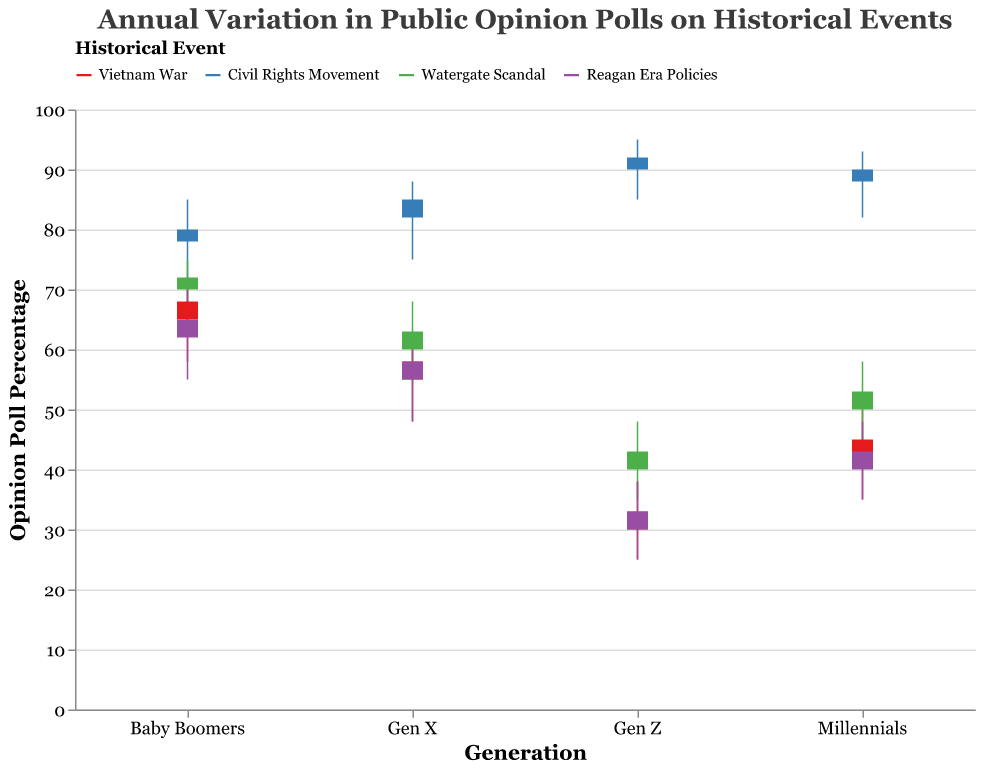What historical event had the highest closing opinion percentage for Baby Boomers? To find this, we look for the historical event where the “Close” value for Baby Boomers is the highest. Baby Boomers have the highest close percentage of 80 for the Civil Rights Movement.
Answer: Civil Rights Movement Which generation had the lowest high opinion percentage for the Vietnam War in 2020? For the Vietnam War in 2020, compare the “High” values among the generations. Gen Z has the lowest high opinion percentage (38).
Answer: Gen Z How does the opening opinion percentage for Reagan Era Policies compare between Baby Boomers and Millennials? Compare the "Open" values for Reagan Era Policies: Baby Boomers (62), Millennials (40). Baby Boomers have a higher opening opinion percentage.
Answer: Baby Boomers have a higher opening opinion What is the range of opinion percentages for Millennials on the Watergate Scandal in 2022? The range is calculated by subtracting the “Low” value from the “High” value for Millennials in 2022 on the Watergate Scandal: 58 - 45 = 13.
Answer: 13 For Gen X, which historical event in the data set had the most variation in opinion percentages from low to high? Calculate the range (High - Low) for each event for Gen X and find the maximum: Vietnam War (62 - 48 = 14), Civil Rights Movement (88 - 75 = 13), Watergate Scandal (68 - 55 = 13), Reagan Era Policies (62 - 48 = 14). Vietnam War and Reagan Era Policies both had variations of 14.
Answer: Vietnam War and Reagan Era Policies What was the closing opinion percentage difference between Gen Z and Millennials for the Civil Rights Movement in 2021? Subtract the "Close" value for Millennials from the "Close" value for Gen Z in 2021 for the Civil Rights Movement: 92 - 90 = 2.
Answer: 2 Which generation had the highest average closing opinion percentage across all the historical events? Calculate the average "Close" values for each generation across all events:
- Baby Boomers: (68 + 80 + 72 + 65) / 4 = 71.25
- Gen X: (58 + 85 + 63 + 58) / 4 = 66
- Millennials: (45 + 90 + 53 + 43) / 4 = 57.75
- Gen Z: (33 + 92 + 43 + 33) / 4 = 50.25
Baby Boomers have the highest average close percentage.
Answer: Baby Boomers How did public opinion (close percentage) on the Watergate Scandal change from Baby Boomers to Gen Z in 2022? Compare the "Close" values for Baby Boomers and Gen Z in 2022 for the Watergate Scandal: Baby Boomers (72), Gen Z (43). The opinion decreased by 29 points.
Answer: Decreased by 29 points Among all generations, which had the greatest opinion drop from open to close for Reagan Era Policies in 2023? Compute the drop (Open - Close) for each generation for Reagan Era Policies in 2023:
- Baby Boomers: 62 - 65 = -3
- Gen X: 55 - 58 = -3
- Millennials: 40 - 43 = -3
- Gen Z: 30 - 33 = -3
All generations show a decrease of 3.
Answer: All generations have the same drop What pattern can be observed about the Civil Rights Movement's opinion percentage across generations in 2021? Examine the "Close" values for each generation for the Civil Rights Movement in 2021: Baby Boomers (80), Gen X (85), Millennials (90), Gen Z (92). The opinion percentage increases progressively from Baby Boomers to Gen Z.
Answer: Increasing trend across generations 